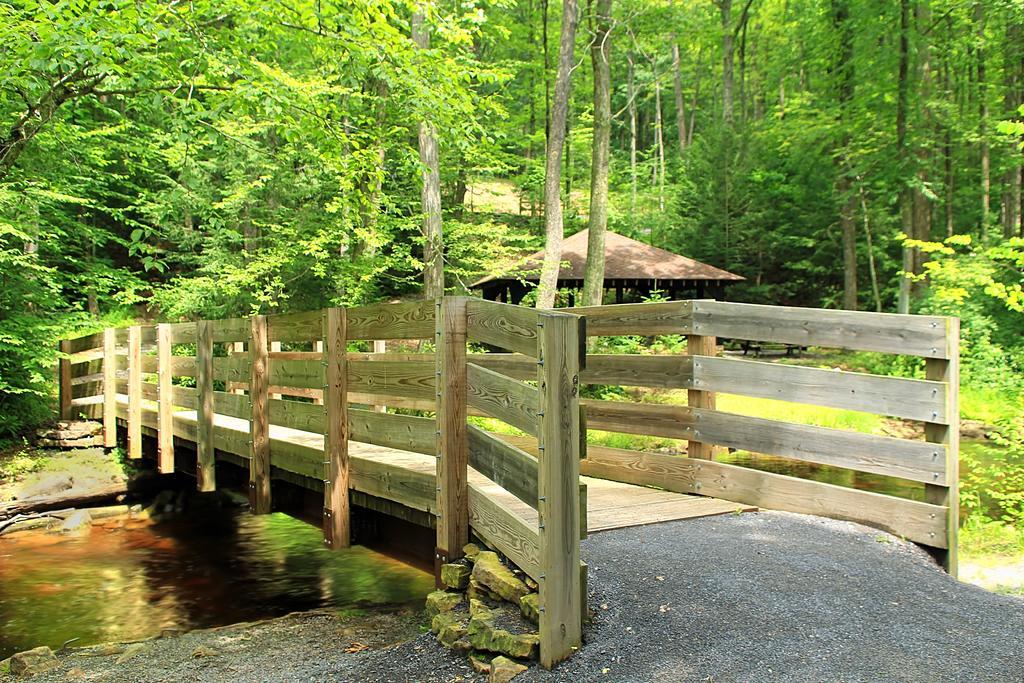Please provide a concise description of this image. In this picture we can see water on the left side, there is a bridge in the middle, we can see some trees and a hut in the background. 